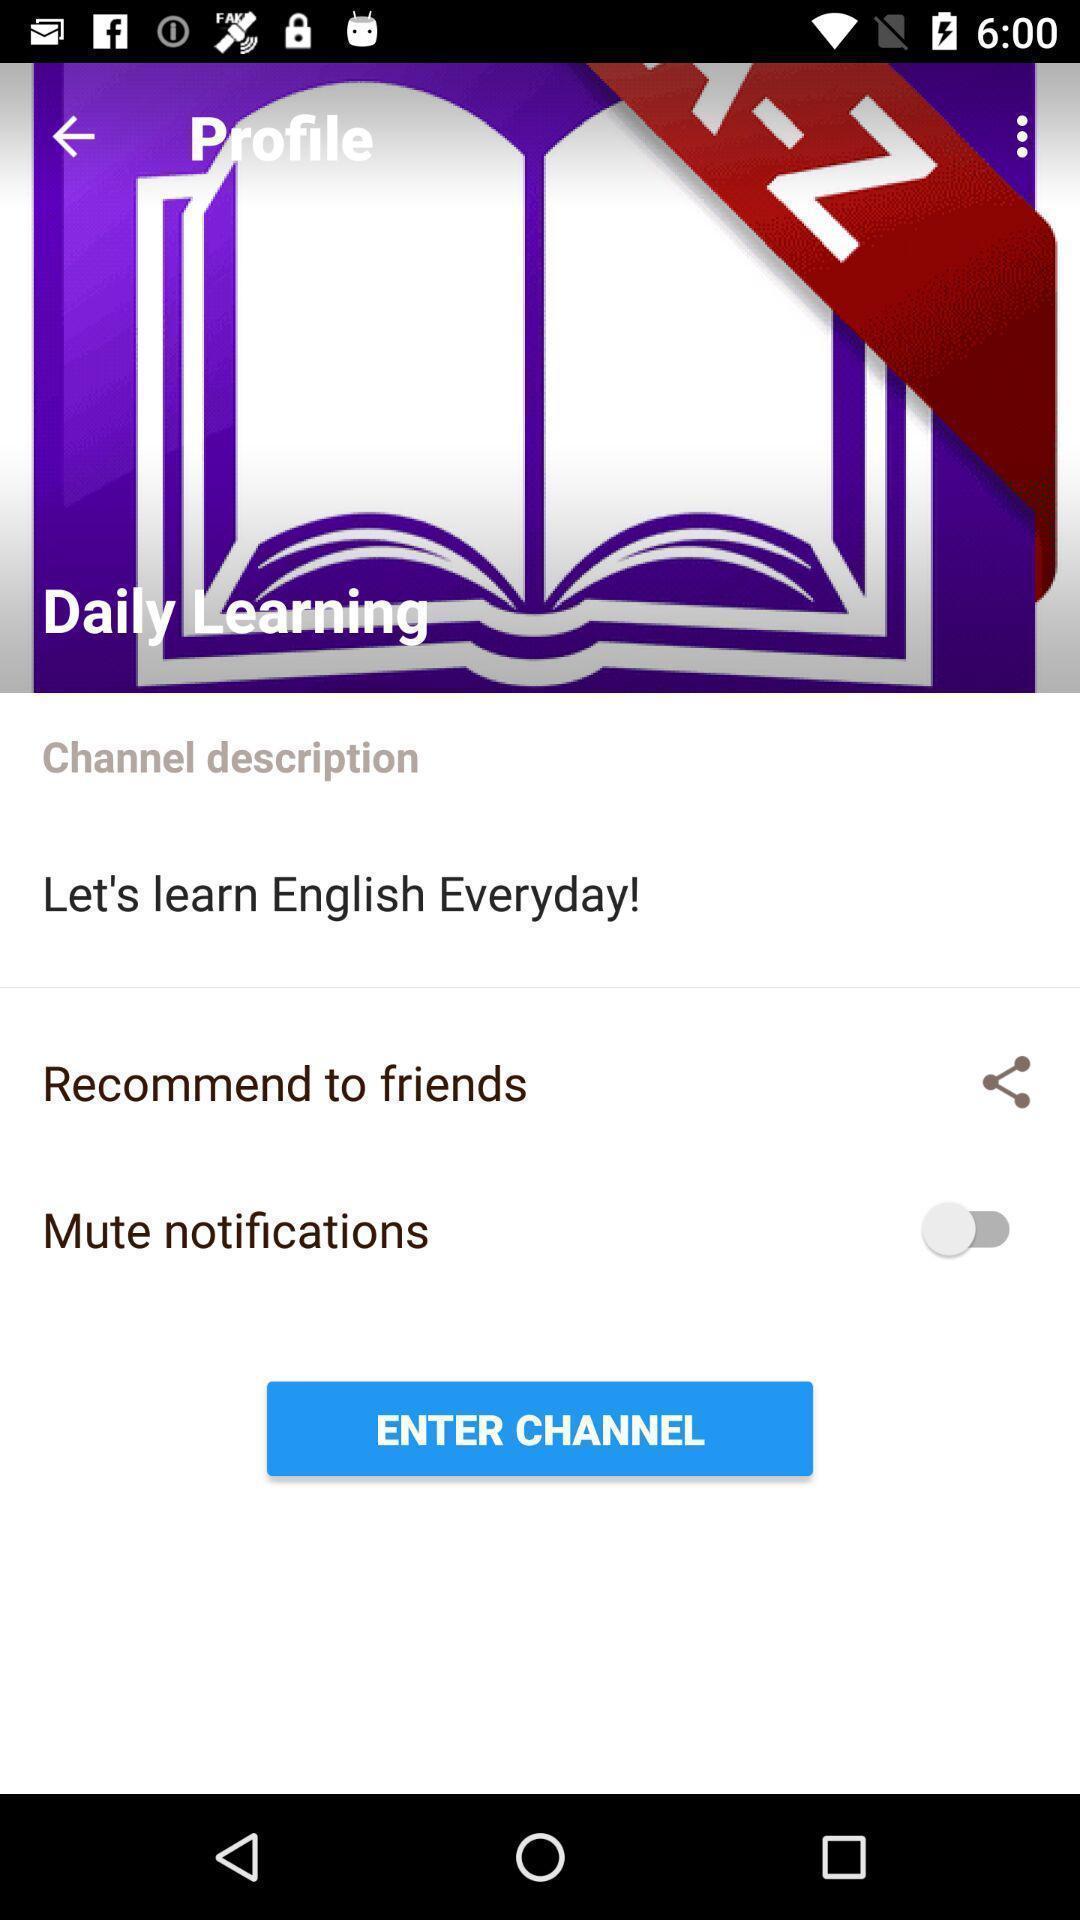Explain the elements present in this screenshot. Screen displaying contents in profile page of a learning application. 